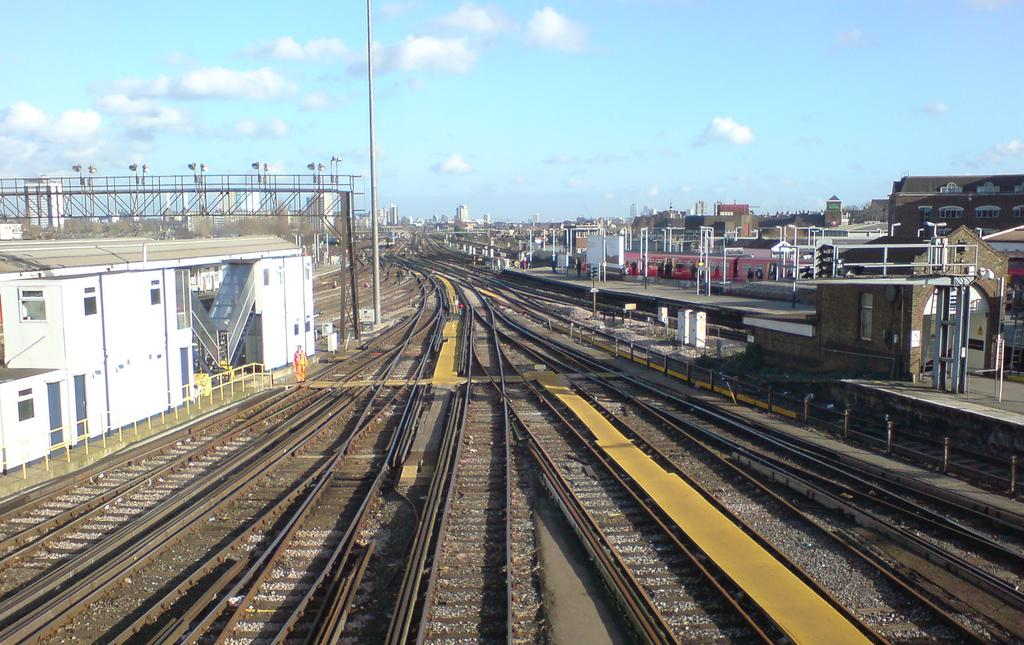What type of transportation infrastructure is visible in the image? There are train tracks in the image. What structure is associated with the train tracks? There is a train station in the image. What object can be seen near the train tracks? There is a pole in the image. What is attached to the pole? There is a light in the image. How would you describe the weather in the image? The sky is cloudy in the image. What type of building is present in the image? There is a building in the image. What feature of the building can be seen? There are windows on the building. Can you tell me how many snails are crawling on the train tracks in the image? There are no snails present on the train tracks in the image. What type of pets can be seen in the windows of the building? There are no pets visible in the windows of the building in the image. 